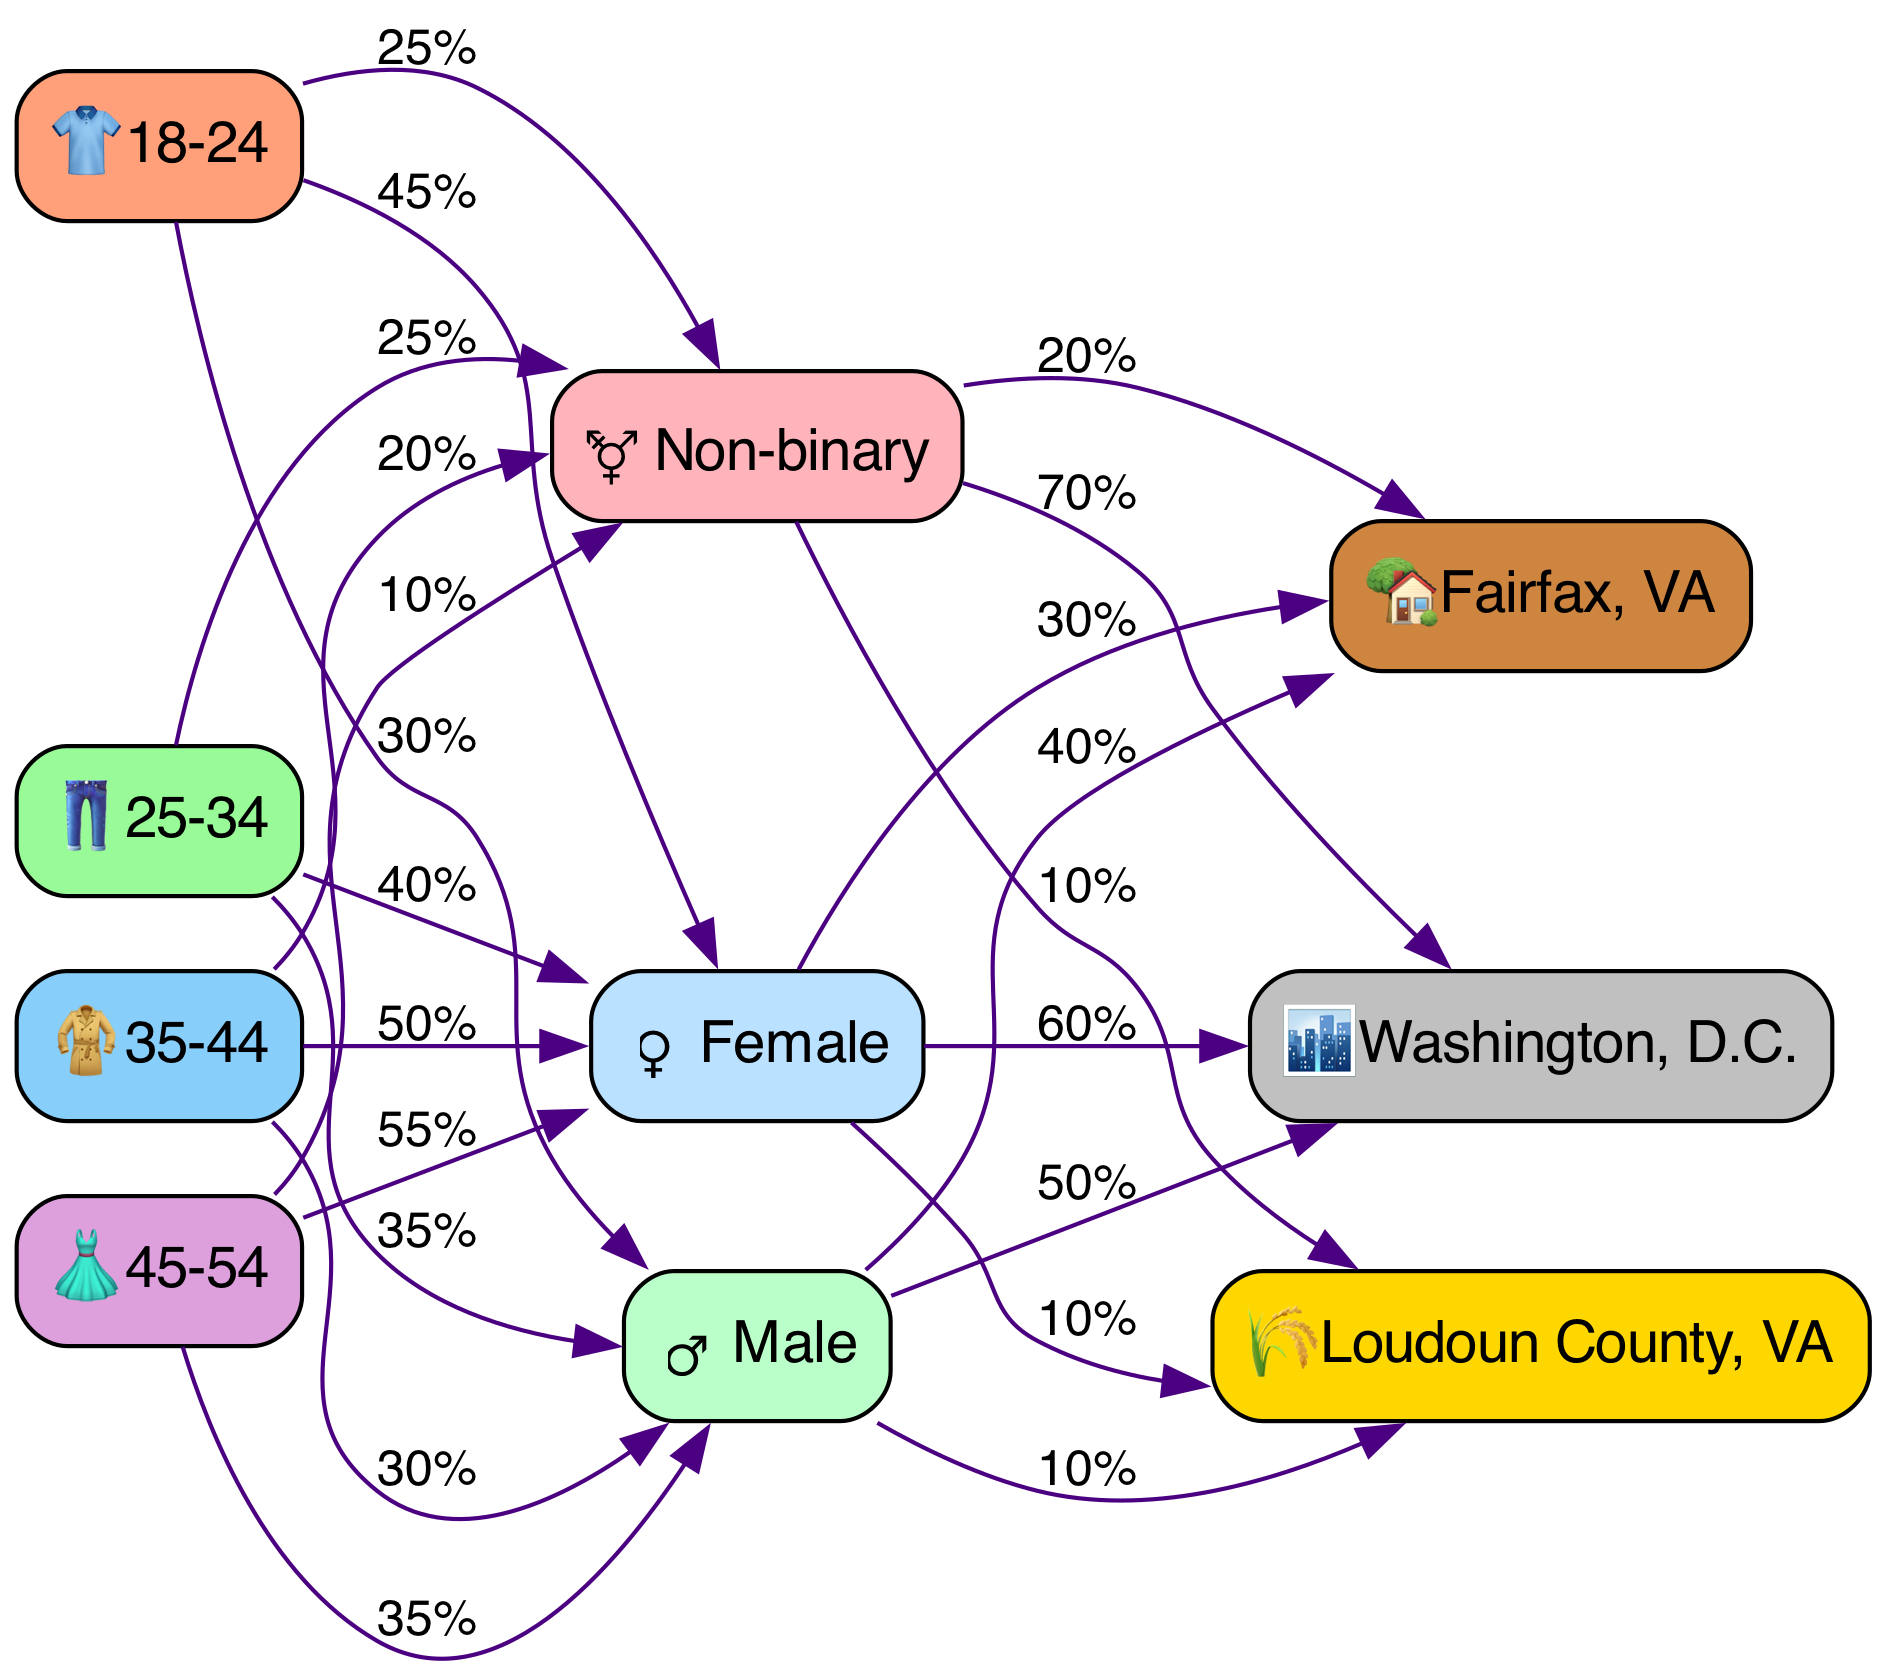What percentage of the 18-24 age group is female? The edge from the "18-24" node to the "Female" node indicates a label of "45%." This shows that 45% of the customers in the 18-24 age group are female.
Answer: 45% Which age group has the highest percentage of males? Analyzing the edges from each age group to the male node, the age group "45-54" has the highest percentage of males with a label of "35%."
Answer: 35% How many total gender categories are represented in the diagram? There are three gender nodes: Male, Female, and Non-binary. This totals to three distinct gender categories represented.
Answer: 3 What is the percentage of non-binary customers located in urban areas? The edge from the "Non-binary" node to the "Washington, D.C." node shows a label of "70%." This indicates that 70% of non-binary customers are located in urban areas.
Answer: 70% Which age group has the lowest representation of non-binary customers? The edge from the "45-54" age group to the "Non-binary" gender shows a label of "10%," which is the lowest representation among all age groups.
Answer: 10% What is the total percentage of females in the 25-34 age group? The edge from the "25-34" age group to the "Female" gender indicates a label of "40%." Therefore, the total percentage of females in this age group is 40%.
Answer: 40% Which location has the highest percentage of female customers? The edge from the "Female" gender to the "Washington, D.C." location indicates "60%," marking it as the location with the highest percentage of female customers.
Answer: 60% What percentage of males are located in suburban areas? The connection from the "Male" gender to the "Fairfax, VA" location shows a label of "40%," indicating that 40% of males are located in suburban areas.
Answer: 40% 